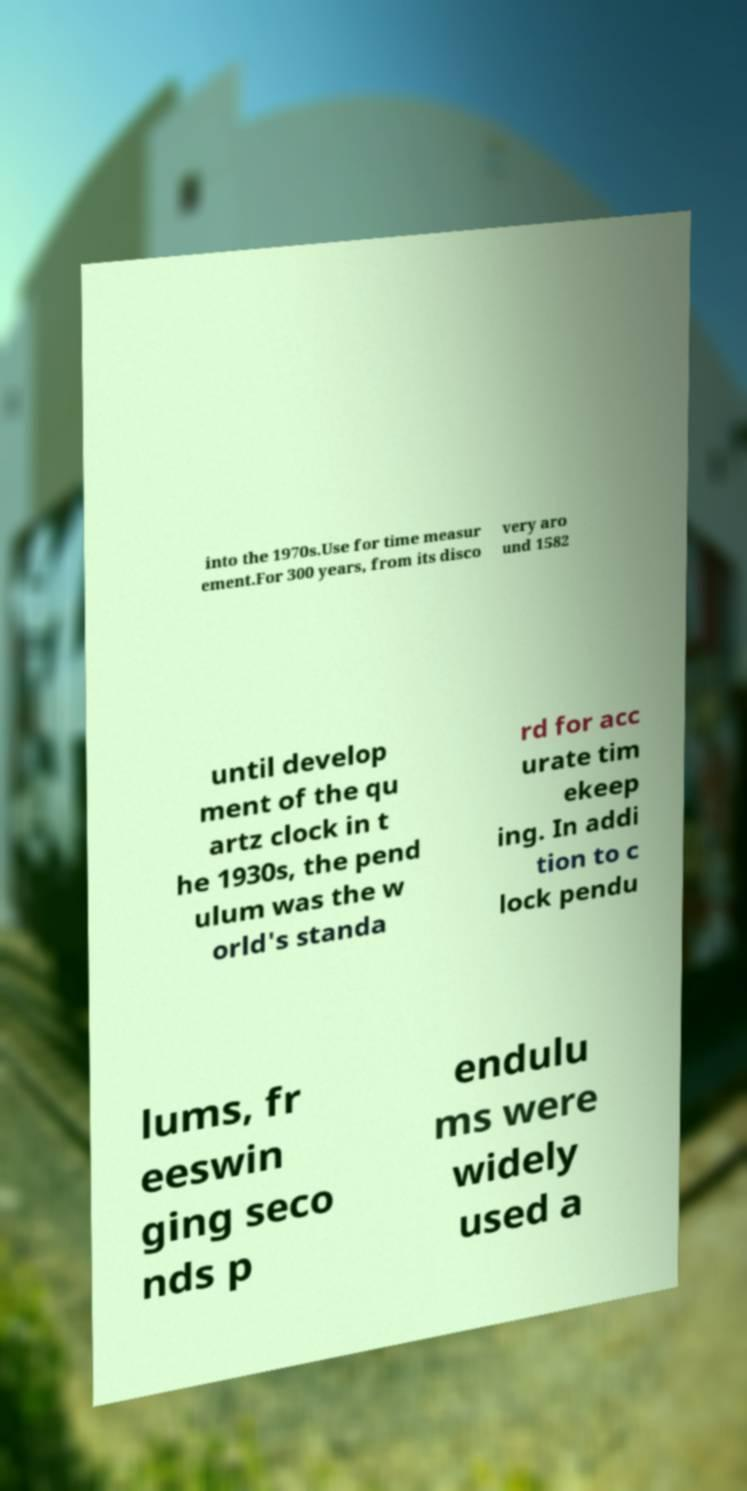For documentation purposes, I need the text within this image transcribed. Could you provide that? into the 1970s.Use for time measur ement.For 300 years, from its disco very aro und 1582 until develop ment of the qu artz clock in t he 1930s, the pend ulum was the w orld's standa rd for acc urate tim ekeep ing. In addi tion to c lock pendu lums, fr eeswin ging seco nds p endulu ms were widely used a 